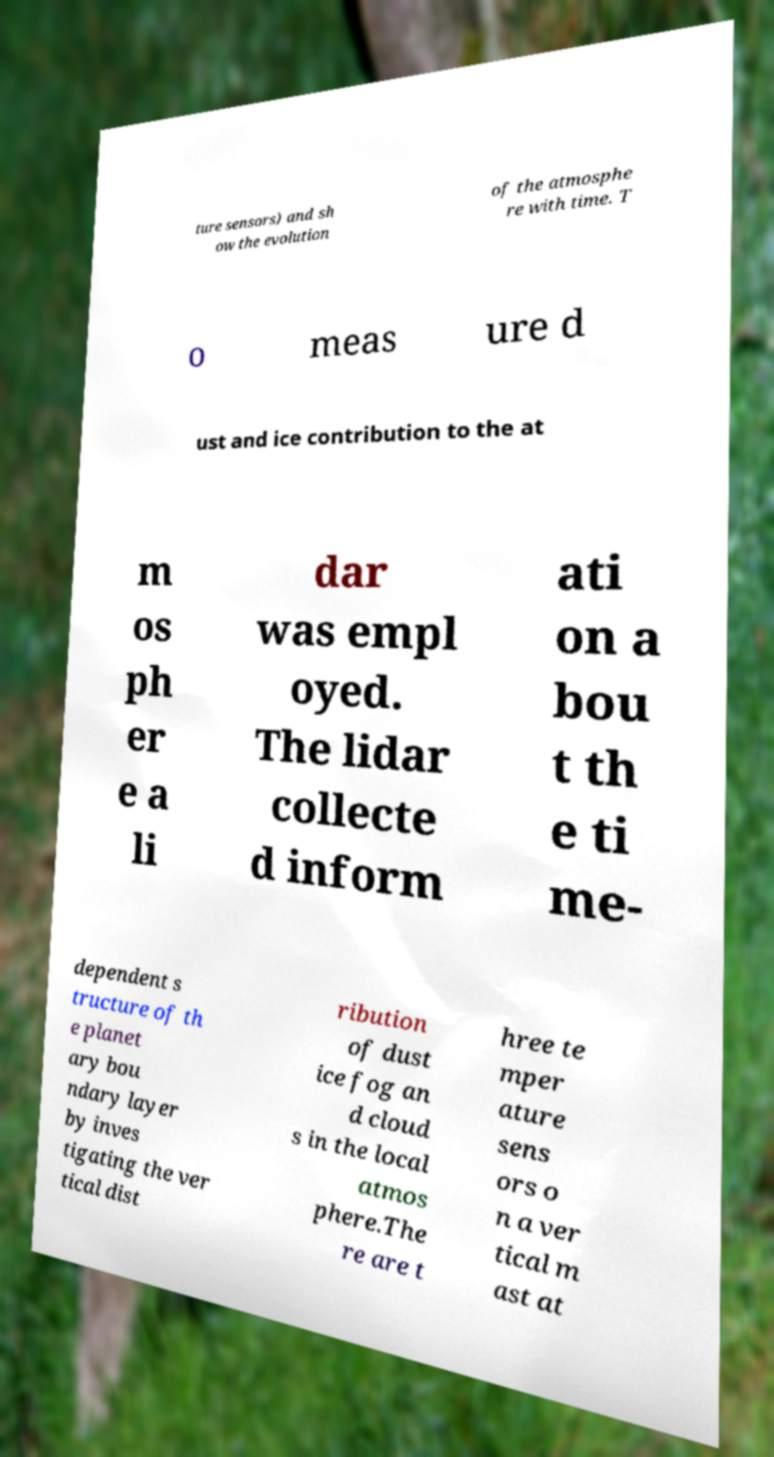What messages or text are displayed in this image? I need them in a readable, typed format. ture sensors) and sh ow the evolution of the atmosphe re with time. T o meas ure d ust and ice contribution to the at m os ph er e a li dar was empl oyed. The lidar collecte d inform ati on a bou t th e ti me- dependent s tructure of th e planet ary bou ndary layer by inves tigating the ver tical dist ribution of dust ice fog an d cloud s in the local atmos phere.The re are t hree te mper ature sens ors o n a ver tical m ast at 